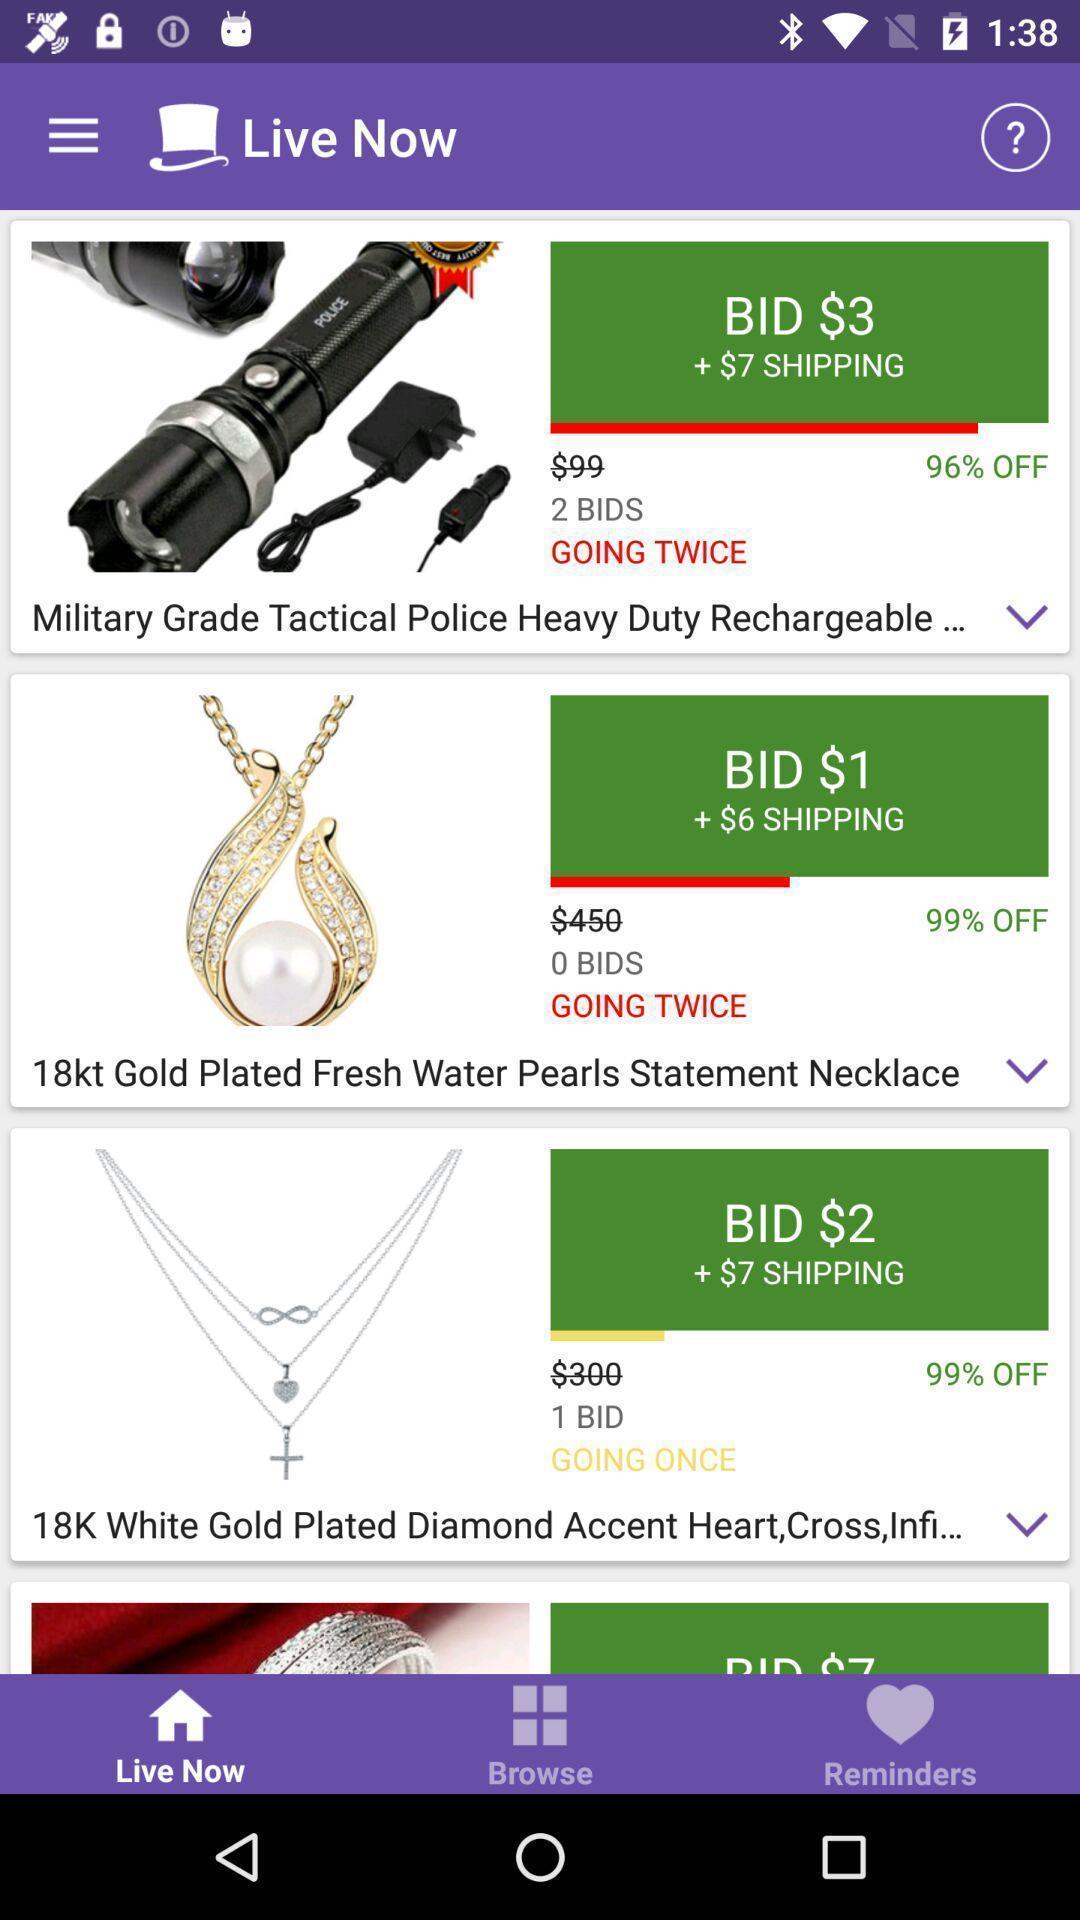Describe the key features of this screenshot. Screen showing page of an shopping application. 